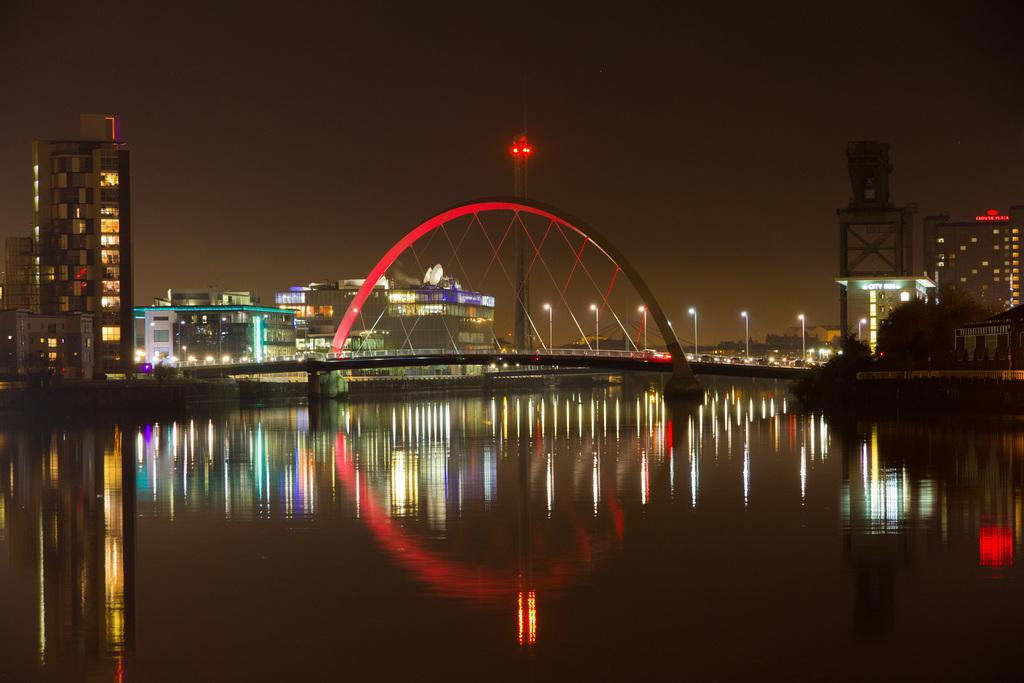What is in the foreground of the image? There is a water surface in the foreground of the image. What can be seen in the background of the image? There are buildings, an arch, poles, light, and the sky visible in the background of the image. Can you tell me how many receipts are floating on the water surface in the image? There are no receipts present in the image; it features a water surface in the foreground. What type of fear is depicted in the image? There is no fear depicted in the image; it features a water surface, buildings, an arch, poles, light, and the sky. 